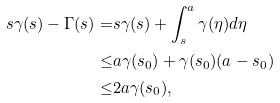<formula> <loc_0><loc_0><loc_500><loc_500>s \gamma ( s ) - \Gamma ( s ) = & s \gamma ( s ) + \int _ { s } ^ { a } \gamma ( \eta ) d \eta \\ \leq & a \gamma ( s _ { 0 } ) + \gamma ( s _ { 0 } ) ( a - s _ { 0 } ) \\ \leq & 2 a \gamma ( s _ { 0 } ) ,</formula> 